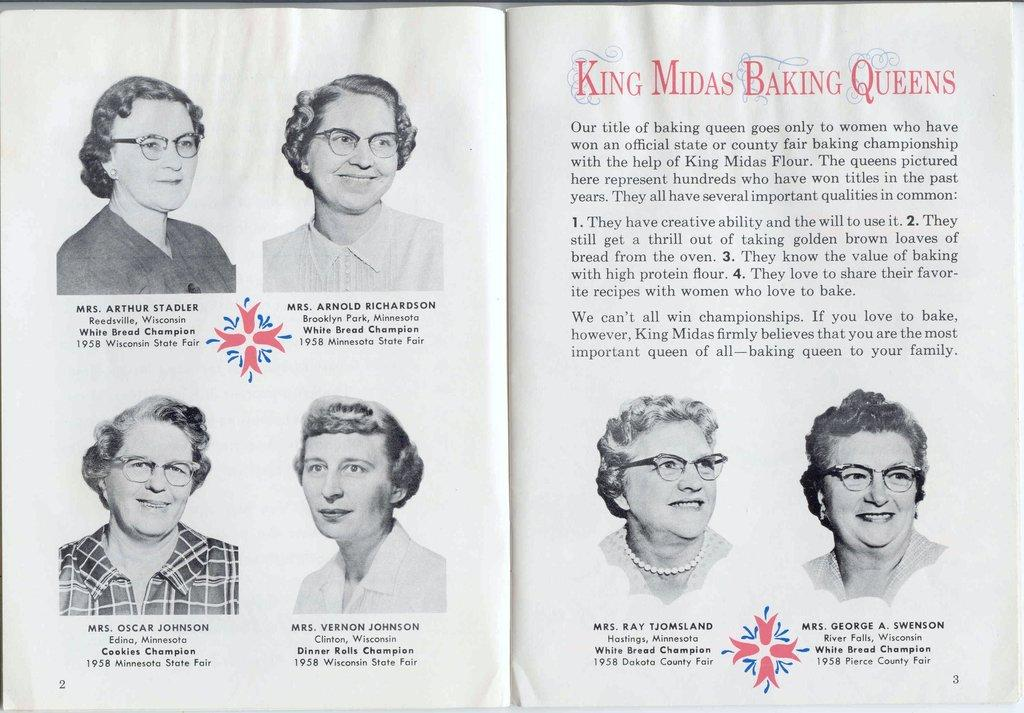What object can be seen in the image? There is a book in the image. Can you describe the people in the image? There is a group of persons in the image. What else is present in the image besides the book and the group of persons? There is some written matter in the image. How many dogs are present in the image? There are no dogs present in the image. What type of trade is being conducted in the image? There is no trade being conducted in the image. 